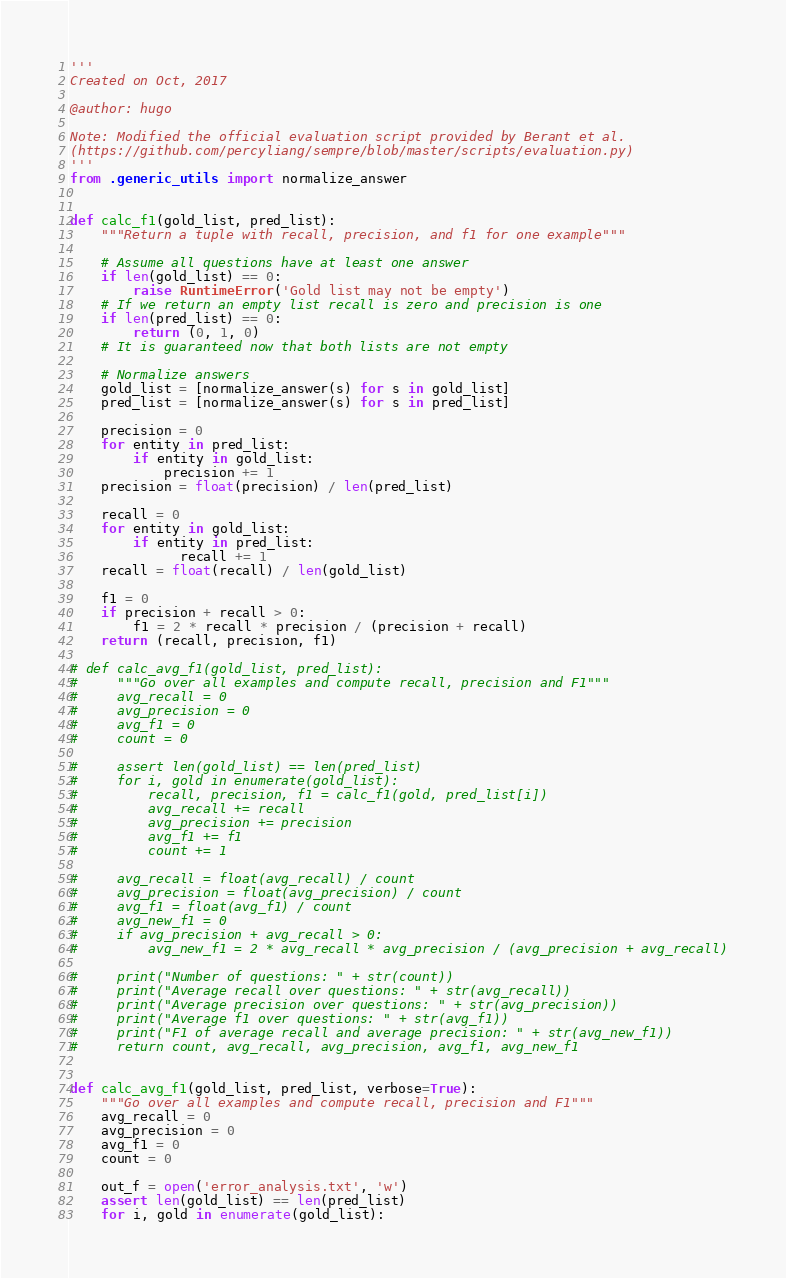<code> <loc_0><loc_0><loc_500><loc_500><_Python_>'''
Created on Oct, 2017

@author: hugo

Note: Modified the official evaluation script provided by Berant et al.
(https://github.com/percyliang/sempre/blob/master/scripts/evaluation.py)
'''
from .generic_utils import normalize_answer


def calc_f1(gold_list, pred_list):
    """Return a tuple with recall, precision, and f1 for one example"""

    # Assume all questions have at least one answer
    if len(gold_list) == 0:
        raise RuntimeError('Gold list may not be empty')
    # If we return an empty list recall is zero and precision is one
    if len(pred_list) == 0:
        return (0, 1, 0)
    # It is guaranteed now that both lists are not empty

    # Normalize answers
    gold_list = [normalize_answer(s) for s in gold_list]
    pred_list = [normalize_answer(s) for s in pred_list]

    precision = 0
    for entity in pred_list:
        if entity in gold_list:
            precision += 1
    precision = float(precision) / len(pred_list)

    recall = 0
    for entity in gold_list:
        if entity in pred_list:
              recall += 1
    recall = float(recall) / len(gold_list)

    f1 = 0
    if precision + recall > 0:
        f1 = 2 * recall * precision / (precision + recall)
    return (recall, precision, f1)

# def calc_avg_f1(gold_list, pred_list):
#     """Go over all examples and compute recall, precision and F1"""
#     avg_recall = 0
#     avg_precision = 0
#     avg_f1 = 0
#     count = 0

#     assert len(gold_list) == len(pred_list)
#     for i, gold in enumerate(gold_list):
#         recall, precision, f1 = calc_f1(gold, pred_list[i])
#         avg_recall += recall
#         avg_precision += precision
#         avg_f1 += f1
#         count += 1

#     avg_recall = float(avg_recall) / count
#     avg_precision = float(avg_precision) / count
#     avg_f1 = float(avg_f1) / count
#     avg_new_f1 = 0
#     if avg_precision + avg_recall > 0:
#         avg_new_f1 = 2 * avg_recall * avg_precision / (avg_precision + avg_recall)

#     print("Number of questions: " + str(count))
#     print("Average recall over questions: " + str(avg_recall))
#     print("Average precision over questions: " + str(avg_precision))
#     print("Average f1 over questions: " + str(avg_f1))
#     print("F1 of average recall and average precision: " + str(avg_new_f1))
#     return count, avg_recall, avg_precision, avg_f1, avg_new_f1


def calc_avg_f1(gold_list, pred_list, verbose=True):
    """Go over all examples and compute recall, precision and F1"""
    avg_recall = 0
    avg_precision = 0
    avg_f1 = 0
    count = 0

    out_f = open('error_analysis.txt', 'w')
    assert len(gold_list) == len(pred_list)
    for i, gold in enumerate(gold_list):</code> 